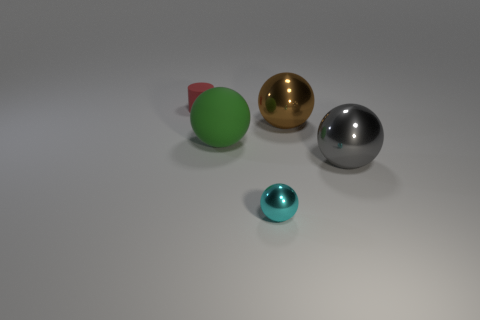Subtract all brown metallic spheres. How many spheres are left? 3 Add 4 large red matte objects. How many objects exist? 9 Add 5 small cylinders. How many small cylinders are left? 6 Add 5 cylinders. How many cylinders exist? 6 Subtract all brown spheres. How many spheres are left? 3 Subtract 0 gray cylinders. How many objects are left? 5 Subtract all cylinders. How many objects are left? 4 Subtract 1 cylinders. How many cylinders are left? 0 Subtract all cyan balls. Subtract all cyan cubes. How many balls are left? 3 Subtract all big metal spheres. Subtract all large green rubber spheres. How many objects are left? 2 